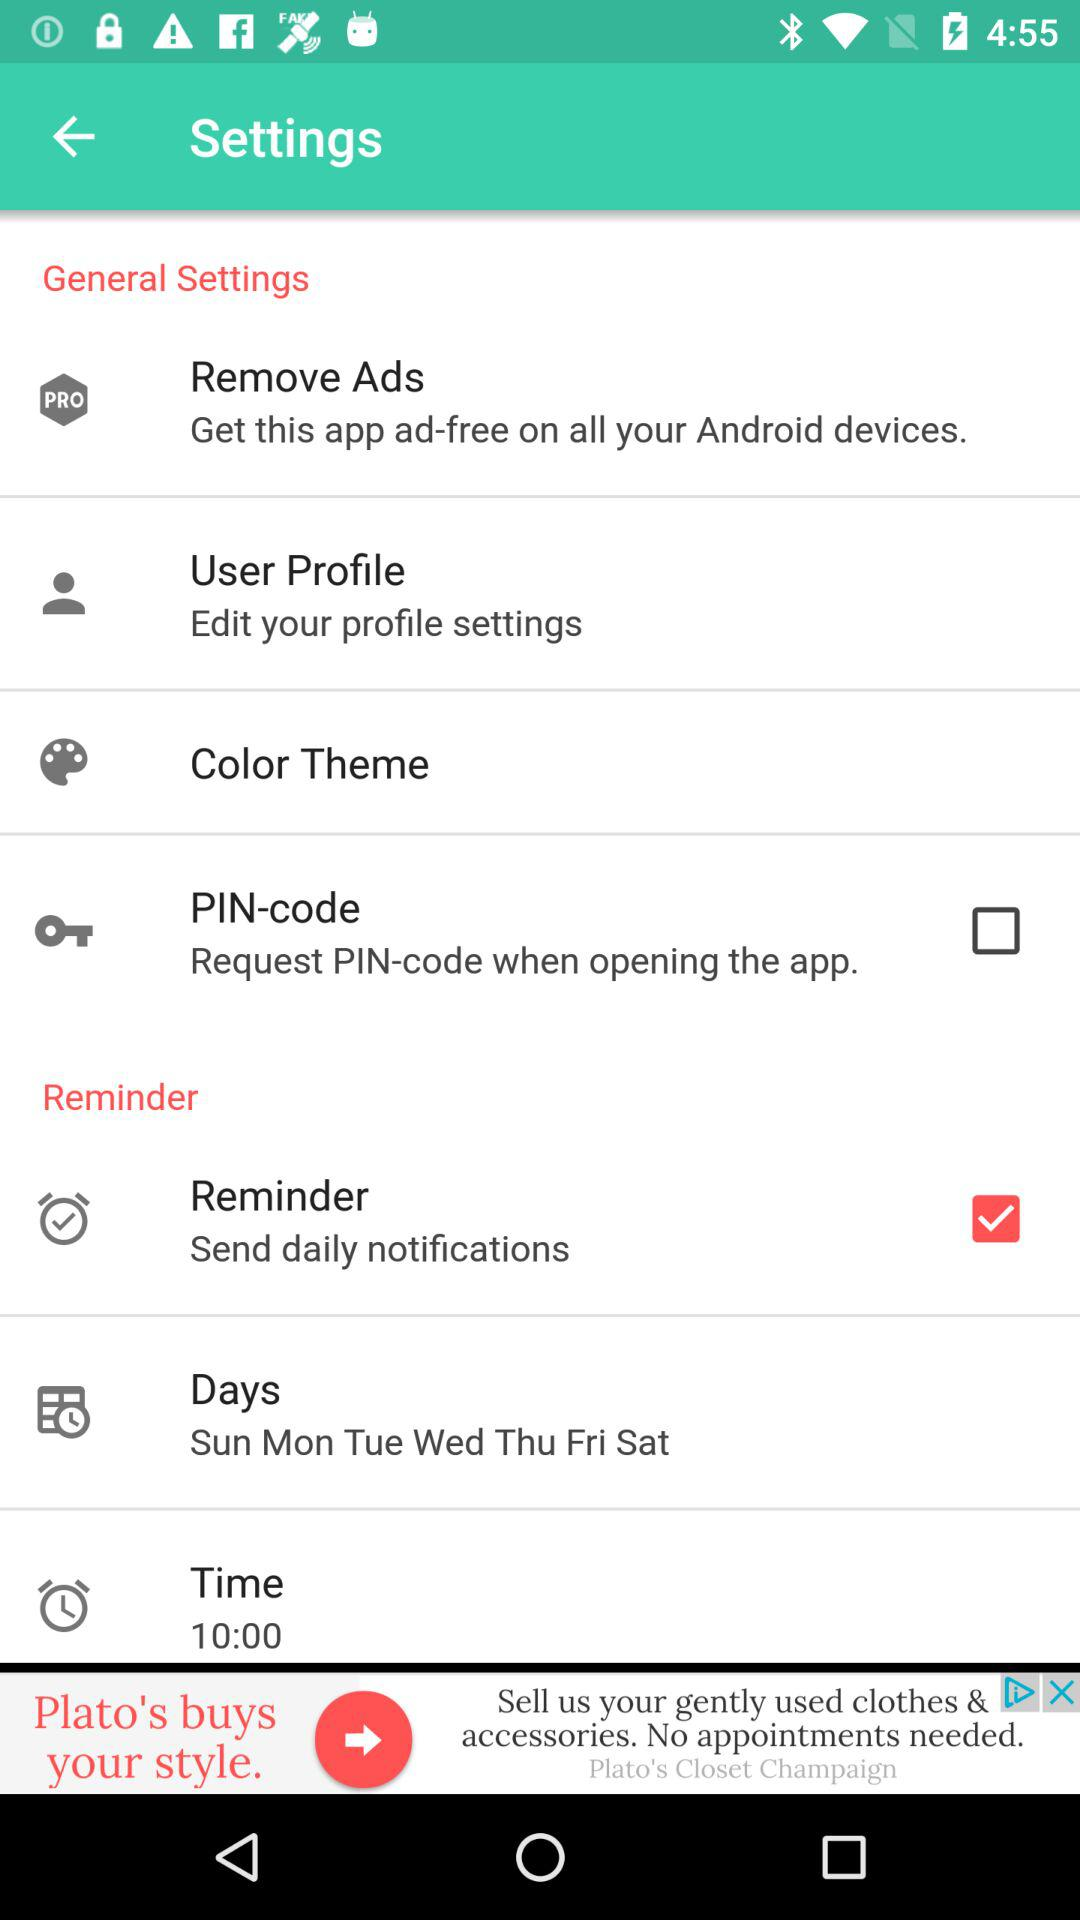What is the status of the reminder? The status is on. 